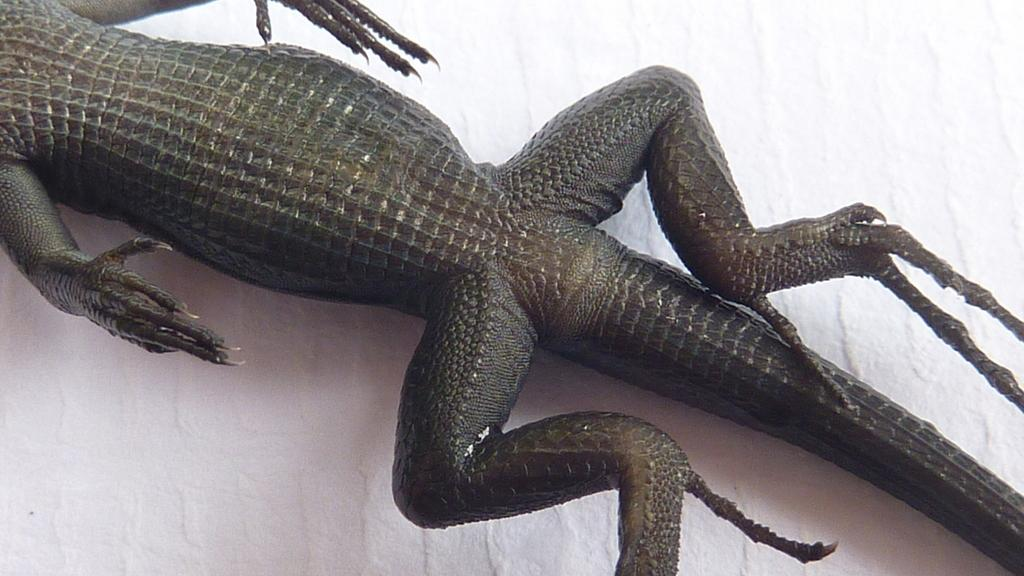What body parts can be seen in the image? Hands and legs are visible in the image. What type of animal is present in the image? The bottom part of a reptile is present in the image. How much credit can be seen in the image? There is no credit visible in the image. What can the hands and legs do with a can in the image? There is no can present in the image, so it is not possible to answer that question. 